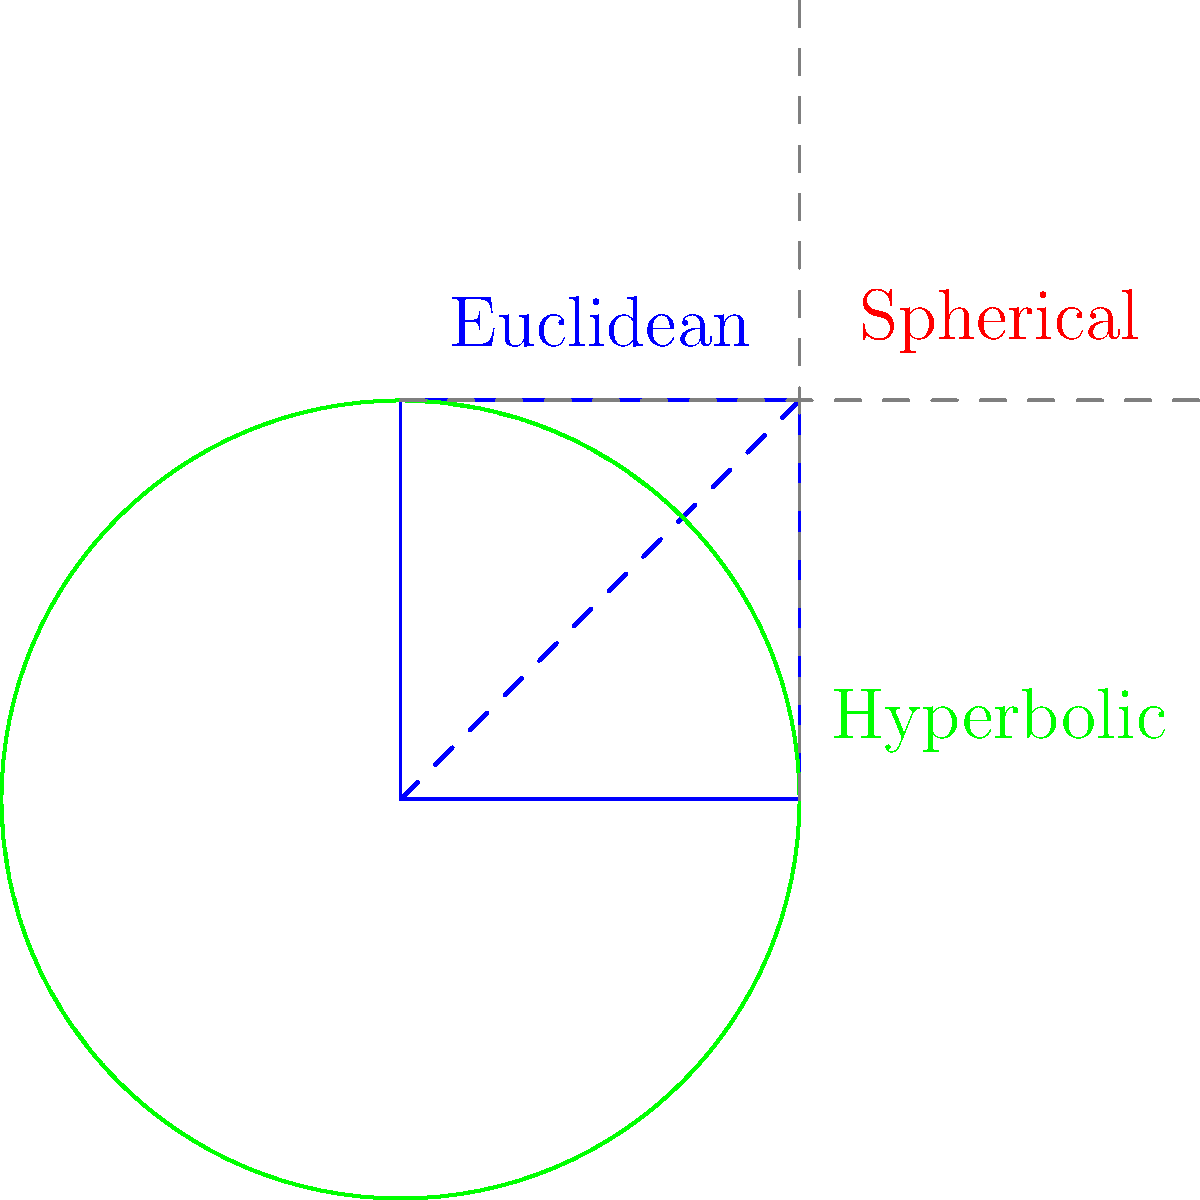In the diagram above, three different geometries are represented: Euclidean (blue), Spherical (red), and Hyperbolic (green). How do the behaviors of "straight lines" differ in these non-Euclidean geometries compared to Euclidean geometry, and what implications might this have for our understanding of spatial relationships in virtual reality environments? To understand the differences in "straight line" behavior across these geometries:

1. Euclidean geometry (blue square):
   - Straight lines are truly straight and extend infinitely.
   - Parallel lines never intersect.
   - The sum of angles in a triangle is always 180°.

2. Spherical geometry (red circle):
   - "Straight lines" are great circles (like the equator on a globe).
   - Any two "straight lines" will intersect at two points.
   - The sum of angles in a triangle is always greater than 180°.

3. Hyperbolic geometry (green circle, Poincaré disk model):
   - "Straight lines" appear curved in this representation.
   - Parallel lines diverge from each other.
   - The sum of angles in a triangle is always less than 180°.

Implications for virtual reality:

1. Spatial perception: Non-Euclidean geometries could create environments that challenge our intuitive understanding of space.

2. Navigation: Users might experience disorientation or motion sickness due to unexpected spatial relationships.

3. Object interaction: Manipulating objects in non-Euclidean spaces could be counterintuitive and require new interaction paradigms.

4. Psychological effects: Exposure to non-Euclidean environments might impact spatial cognition and decision-making processes.

5. Limitations of VR: Current VR technology may struggle to accurately represent the complexities of non-Euclidean geometries, potentially leading to inconsistencies in user experience.

These differences highlight the challenge of replicating the full complexity of real-world spatial relationships in virtual environments, supporting the perspective that VR may not fully capture the nuances of real-life human interactions and spatial experiences.
Answer: Non-Euclidean geometries alter the behavior of "straight lines," affecting spatial relationships and navigation in ways that challenge intuitive understanding, potentially limiting VR's ability to replicate real-world spatial complexities. 